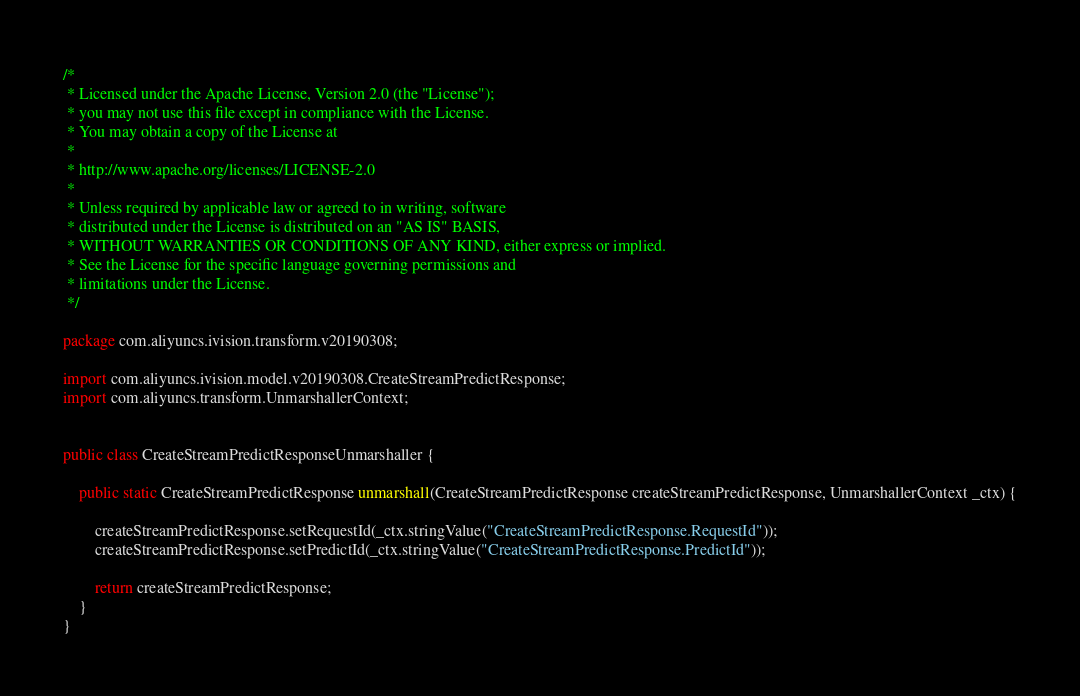Convert code to text. <code><loc_0><loc_0><loc_500><loc_500><_Java_>/*
 * Licensed under the Apache License, Version 2.0 (the "License");
 * you may not use this file except in compliance with the License.
 * You may obtain a copy of the License at
 *
 * http://www.apache.org/licenses/LICENSE-2.0
 *
 * Unless required by applicable law or agreed to in writing, software
 * distributed under the License is distributed on an "AS IS" BASIS,
 * WITHOUT WARRANTIES OR CONDITIONS OF ANY KIND, either express or implied.
 * See the License for the specific language governing permissions and
 * limitations under the License.
 */

package com.aliyuncs.ivision.transform.v20190308;

import com.aliyuncs.ivision.model.v20190308.CreateStreamPredictResponse;
import com.aliyuncs.transform.UnmarshallerContext;


public class CreateStreamPredictResponseUnmarshaller {

	public static CreateStreamPredictResponse unmarshall(CreateStreamPredictResponse createStreamPredictResponse, UnmarshallerContext _ctx) {
		
		createStreamPredictResponse.setRequestId(_ctx.stringValue("CreateStreamPredictResponse.RequestId"));
		createStreamPredictResponse.setPredictId(_ctx.stringValue("CreateStreamPredictResponse.PredictId"));
	 
	 	return createStreamPredictResponse;
	}
}</code> 